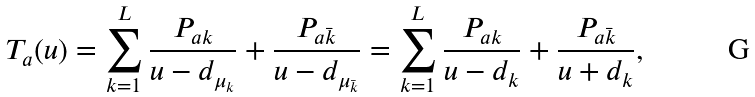Convert formula to latex. <formula><loc_0><loc_0><loc_500><loc_500>T _ { a } ( u ) = \sum _ { k = 1 } ^ { L } \frac { P _ { a k } } { u - d _ { \mu _ { k } } } + \frac { P _ { a \bar { k } } } { u - d _ { \mu _ { \bar { k } } } } = \sum _ { k = 1 } ^ { L } \frac { P _ { a k } } { u - d _ { k } } + \frac { P _ { a \bar { k } } } { u + d _ { k } } ,</formula> 